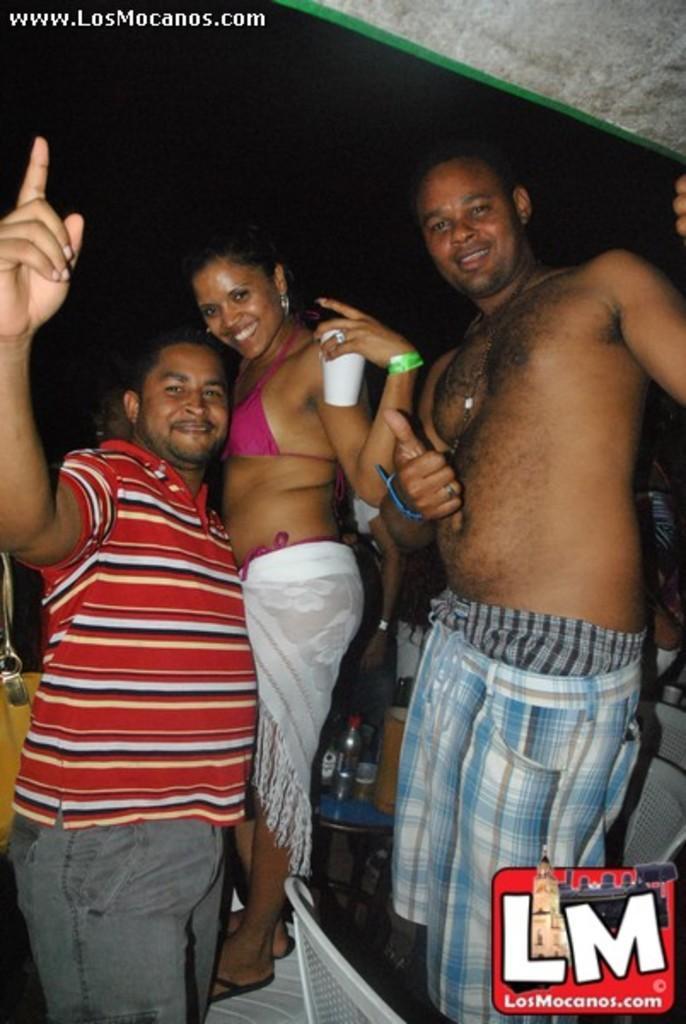Can you describe this image briefly? In the center of the image a lady is standing and holding a glass. On the left and right side of the image two mans are standing. In the middle of the image there is a table. On the table we can see bottles are there. At the bottom of the image chairs are there. 